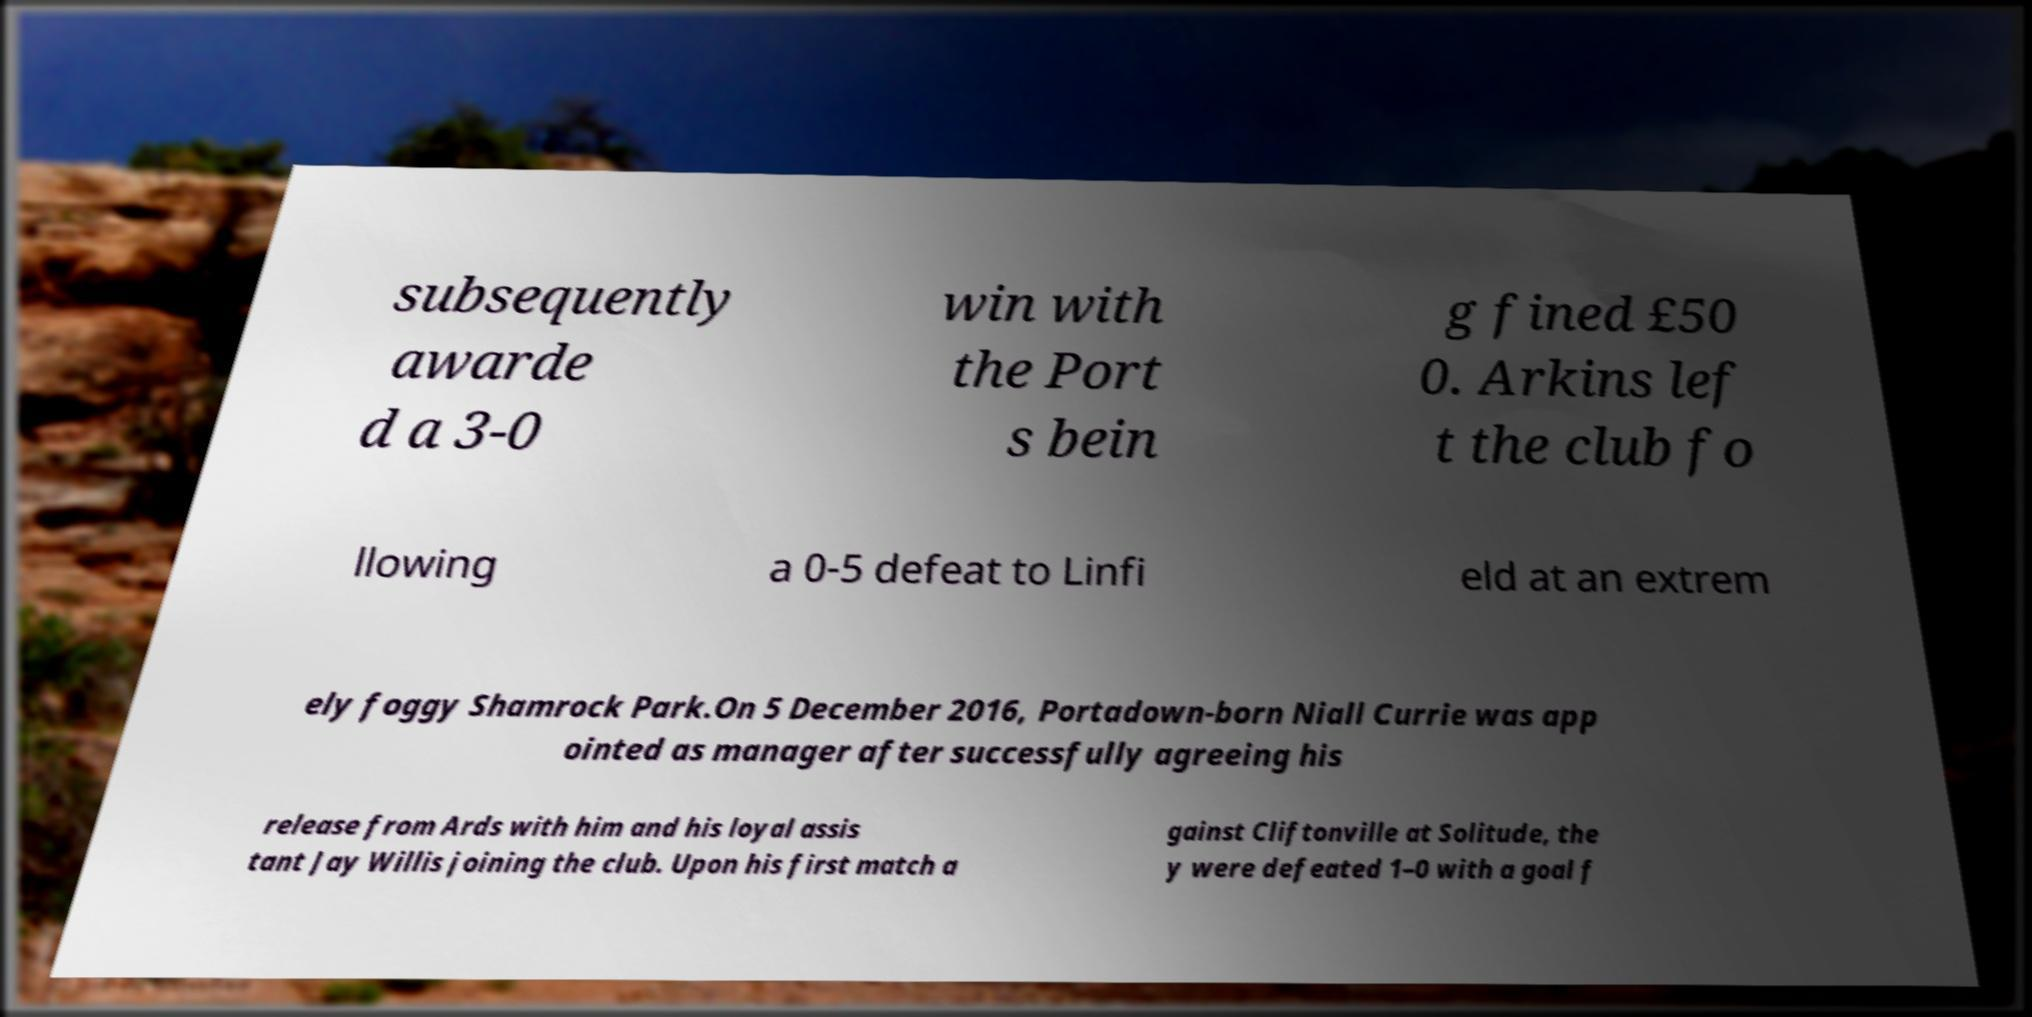Can you read and provide the text displayed in the image?This photo seems to have some interesting text. Can you extract and type it out for me? subsequently awarde d a 3-0 win with the Port s bein g fined £50 0. Arkins lef t the club fo llowing a 0-5 defeat to Linfi eld at an extrem ely foggy Shamrock Park.On 5 December 2016, Portadown-born Niall Currie was app ointed as manager after successfully agreeing his release from Ards with him and his loyal assis tant Jay Willis joining the club. Upon his first match a gainst Cliftonville at Solitude, the y were defeated 1–0 with a goal f 